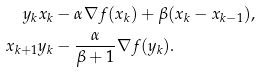<formula> <loc_0><loc_0><loc_500><loc_500>y _ { k } & x _ { k } - \alpha \nabla f ( x _ { k } ) + \beta ( x _ { k } - x _ { k - 1 } ) , \\ x _ { k + 1 } & y _ { k } - \frac { \alpha } { \beta + 1 } \nabla f ( y _ { k } ) .</formula> 